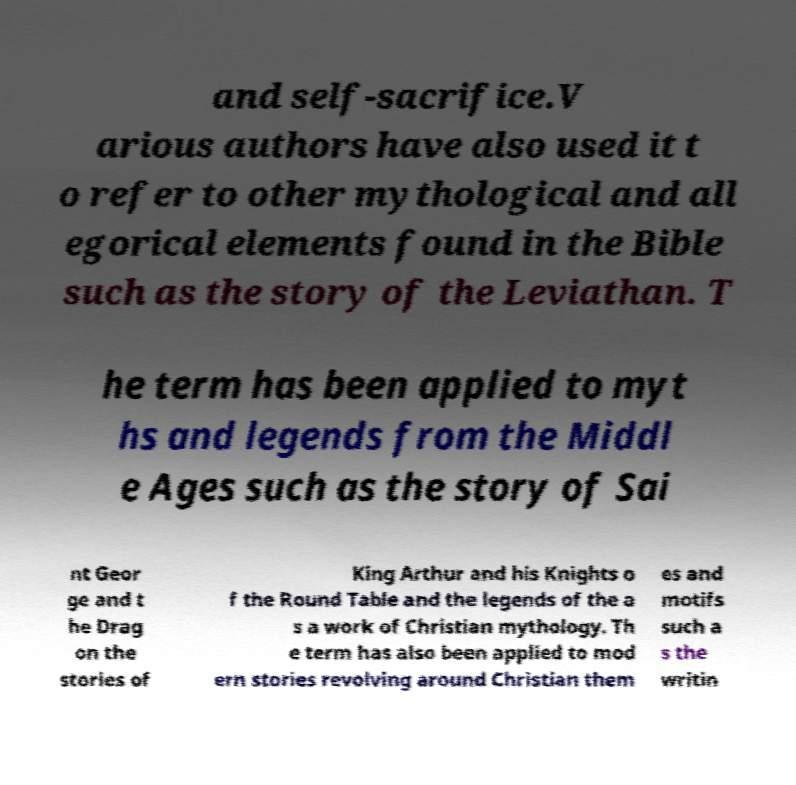Could you extract and type out the text from this image? and self-sacrifice.V arious authors have also used it t o refer to other mythological and all egorical elements found in the Bible such as the story of the Leviathan. T he term has been applied to myt hs and legends from the Middl e Ages such as the story of Sai nt Geor ge and t he Drag on the stories of King Arthur and his Knights o f the Round Table and the legends of the a s a work of Christian mythology. Th e term has also been applied to mod ern stories revolving around Christian them es and motifs such a s the writin 